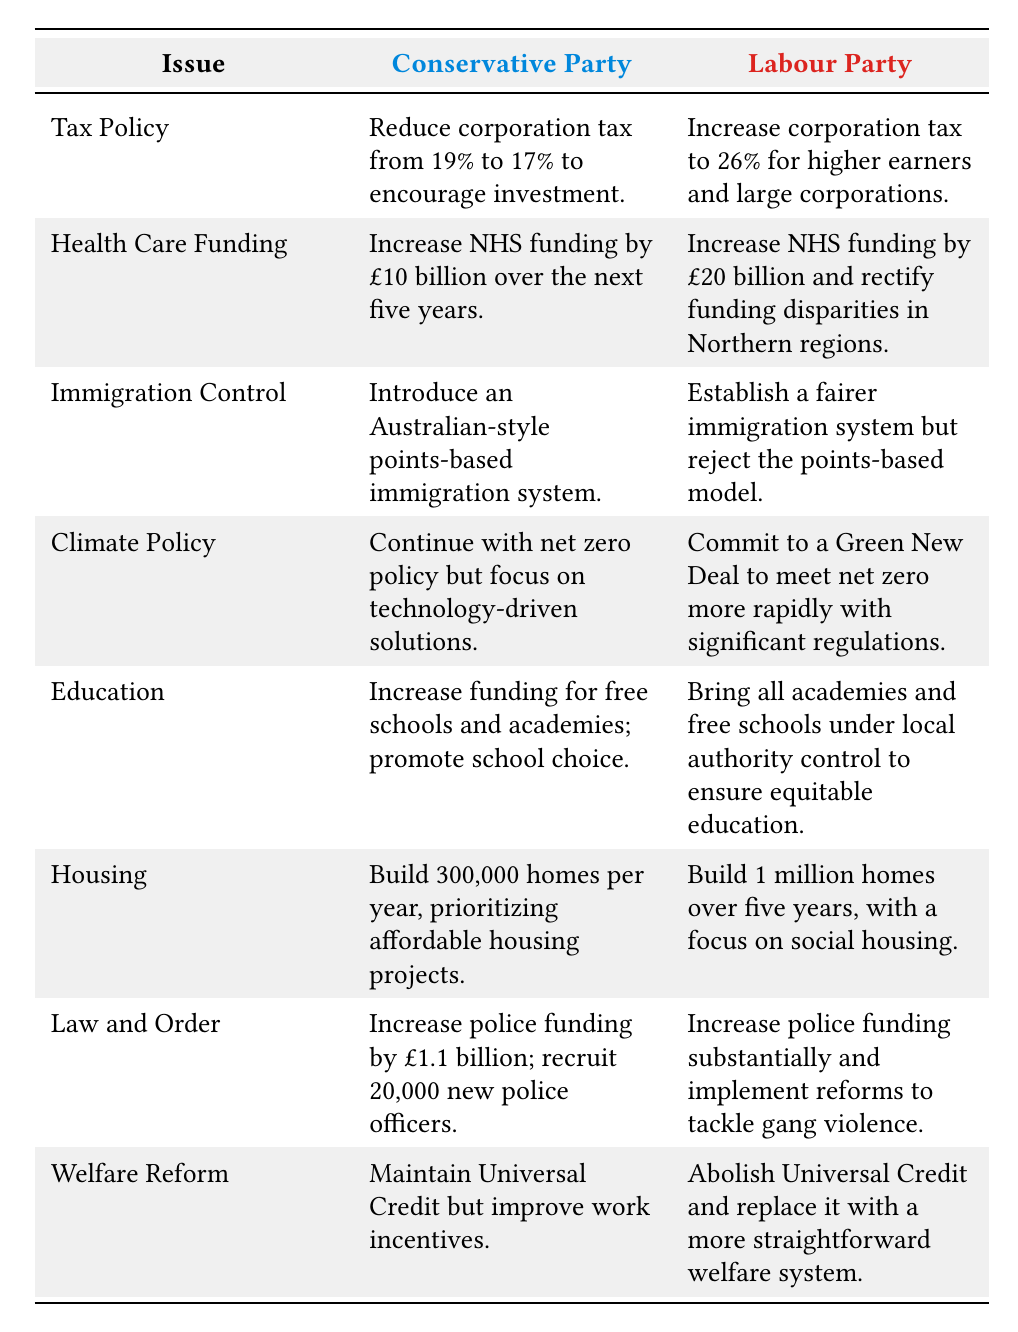What is the Conservative Party's proposal for tax policy? According to the table, the Conservative Party proposes to reduce corporation tax from 19% to 17% to encourage investment.
Answer: Reduce corporation tax from 19% to 17% to encourage investment What funding increase does the Labour Party propose for the NHS? The table indicates that the Labour Party proposes to increase NHS funding by £20 billion and rectify funding disparities in Northern regions.
Answer: Increase NHS funding by £20 billion and rectify funding disparities in Northern regions Does the Conservative Party support a points-based immigration system? The table shows that the Conservative Party plans to introduce an Australian-style points-based immigration system, while the Labour Party rejects this model. Thus, the Conservative Party does support it.
Answer: Yes Which party proposes to build more houses, and what is their target? The Labour Party proposes to build 1 million homes over five years with a focus on social housing, while the Conservative Party aims to build 300,000 homes per year. Comparing these figures shows Labour has a more ambitious target.
Answer: Labour Party (1 million homes) How much police funding does the Conservative Party propose to increase? The table states that the Conservative Party plans to increase police funding by £1.1 billion and recruit 20,000 new police officers, providing a specific figure.
Answer: Increase police funding by £1.1 billion What are the two main focuses of the Conservative Party’s climate policy? The Conservative Party plans to continue with the net zero policy but emphasizes focusing on technology-driven solutions, which are noted as the two key components in their climate strategy.
Answer: Net zero policy and technology-driven solutions Is the Labour Party's proposal for welfare reform in favor of maintaining Universal Credit? The table shows that the Labour Party proposes to abolish Universal Credit and replace it with a different welfare system, indicating they do not support maintaining it.
Answer: No Which party aims for a quicker approach to reaching net zero, and how do they plan to achieve it? The table reveals that the Labour Party commits to a Green New Deal to meet net zero more rapidly with significant regulations, thus proposing a quicker approach compared to the Conservative Party.
Answer: Labour Party; Green New Deal with significant regulations 